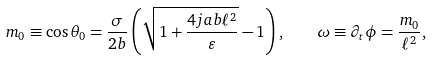Convert formula to latex. <formula><loc_0><loc_0><loc_500><loc_500>m _ { 0 } \equiv \cos \theta _ { 0 } = \frac { \sigma } { 2 b } \left ( \sqrt { 1 + \frac { 4 j a b \ell ^ { 2 } } { \varepsilon } } - 1 \right ) , \quad \omega \equiv \partial _ { t } \phi = \frac { m _ { 0 } } { \ell ^ { 2 } } ,</formula> 